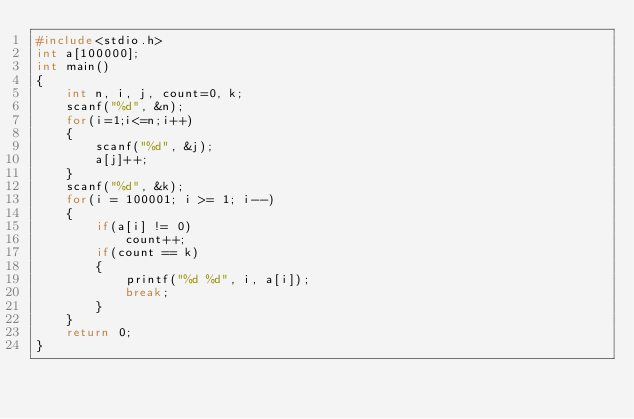<code> <loc_0><loc_0><loc_500><loc_500><_C_>#include<stdio.h>
int a[100000];
int main()
{
	int n, i, j, count=0, k;
	scanf("%d", &n);
	for(i=1;i<=n;i++)
	{
		scanf("%d", &j);
		a[j]++;
	}
	scanf("%d", &k);
	for(i = 100001; i >= 1; i--)
	{
		if(a[i] != 0)
			count++;
		if(count == k)
		{
			printf("%d %d", i, a[i]);
			break;
		}
	}
	return 0;
}</code> 